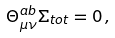Convert formula to latex. <formula><loc_0><loc_0><loc_500><loc_500>\Theta _ { \mu \nu } ^ { a b } \Sigma _ { t o t } = 0 \, ,</formula> 